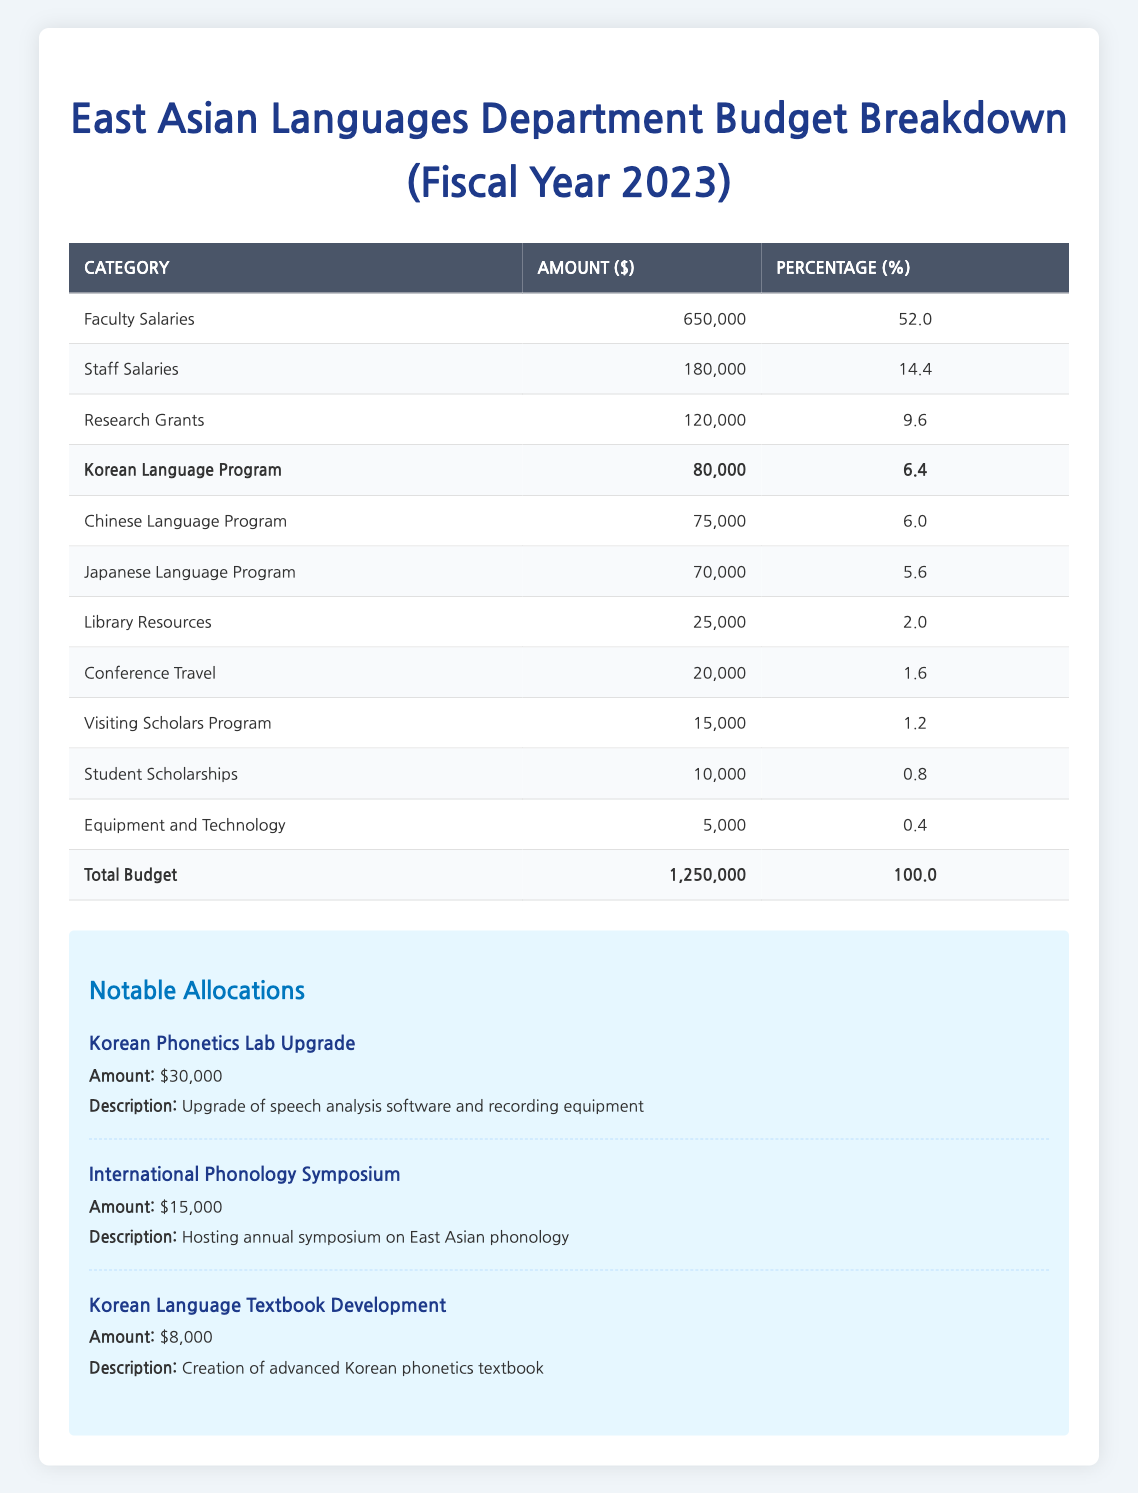What's the total budget for the East Asian Languages department in 2023? The total budget is provided directly in the table. It states that the total budget is 1,250,000.
Answer: 1,250,000 How much of the budget is allocated to Faculty Salaries? The table specifically mentions that 650,000 is allocated for Faculty Salaries in the budget breakdown.
Answer: 650,000 What percentage of the total budget is allocated for Student Scholarships? The table specifies that Student Scholarships receive 10,000, which is 0.8 percent of the total budget. This information is explicitly mentioned in the budget breakdown.
Answer: 0.8 Which language program has the highest allocation? Comparing the amounts allocated, the Korean Language Program has 80,000, while the Chinese and Japanese programs have 75,000 and 70,000 respectively. Thus, the Korean Language Program has the highest allocation.
Answer: Korean Language Program How much more is allocated to Faculty Salaries compared to Staff Salaries? The amount for Faculty Salaries is 650,000 and for Staff Salaries, it is 180,000. To find the difference, subtract 180,000 from 650,000: 650,000 - 180,000 = 470,000.
Answer: 470,000 True or False: The budget for the Japanese Language Program is higher than that for Library Resources. The Japanese Language Program is allocated 70,000, while Library Resources receive 25,000. Since 70,000 is greater than 25,000, the statement is true.
Answer: True What is the total allocation for the three language programs combined? The allocations for the Korean, Chinese, and Japanese language programs are 80,000, 75,000, and 70,000 respectively. Summing these amounts gives: 80,000 + 75,000 + 70,000 = 225,000.
Answer: 225,000 What percentage of the total budget is spent on Research Grants? The budget breakdown for Research Grants indicates 120,000, which makes up 9.6 percent of the total budget. This is directly stated in the table.
Answer: 9.6 How much funding is allocated for notable projects compared to the total budget? The notable allocations total 53,000 (30,000 + 15,000 + 8,000). To see what percentage this constitutes of the total budget, divide 53,000 by 1,250,000: (53,000 / 1,250,000) * 100 = 4.24 percent.
Answer: 4.24 percent 